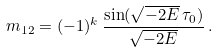Convert formula to latex. <formula><loc_0><loc_0><loc_500><loc_500>m _ { 1 2 } = ( - 1 ) ^ { k } \, \frac { \sin ( \sqrt { - 2 E } \, \tau _ { 0 } ) } { \sqrt { - 2 E } } \, .</formula> 